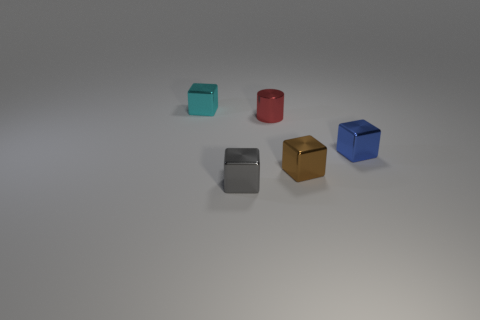There is a thing that is in front of the brown thing; is it the same shape as the small cyan object?
Keep it short and to the point. Yes. Are there any small red metallic objects?
Your answer should be compact. Yes. Is there anything else that has the same shape as the red thing?
Your response must be concise. No. Is the number of gray shiny blocks in front of the red object greater than the number of green metal cylinders?
Ensure brevity in your answer.  Yes. There is a small brown metallic thing; are there any tiny brown shiny things left of it?
Provide a succinct answer. No. The gray thing that is the same shape as the small blue thing is what size?
Offer a terse response. Small. Is there anything else that has the same size as the brown shiny object?
Give a very brief answer. Yes. What is the material of the block that is to the left of the metal object that is in front of the brown shiny block?
Provide a succinct answer. Metal. Does the tiny blue metallic thing have the same shape as the small red metallic thing?
Provide a succinct answer. No. What number of small objects are in front of the brown object and behind the brown metallic block?
Keep it short and to the point. 0. 